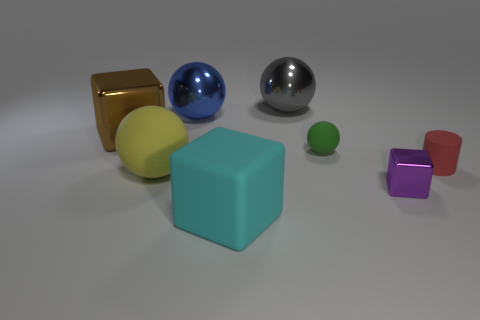There is a small rubber object that is to the left of the tiny rubber cylinder; what is its shape?
Your response must be concise. Sphere. What number of yellow matte balls are the same size as the gray object?
Offer a terse response. 1. What size is the purple object?
Provide a short and direct response. Small. What number of tiny red things are on the left side of the big brown cube?
Ensure brevity in your answer.  0. The cyan object that is the same material as the small cylinder is what shape?
Provide a short and direct response. Cube. Are there fewer large shiny spheres on the left side of the gray object than things that are behind the red cylinder?
Make the answer very short. Yes. Is the number of tiny purple objects greater than the number of rubber balls?
Give a very brief answer. No. What material is the gray thing?
Offer a very short reply. Metal. The large sphere in front of the matte cylinder is what color?
Provide a succinct answer. Yellow. Is the number of metal objects that are to the right of the gray shiny ball greater than the number of rubber balls behind the small sphere?
Offer a very short reply. Yes. 